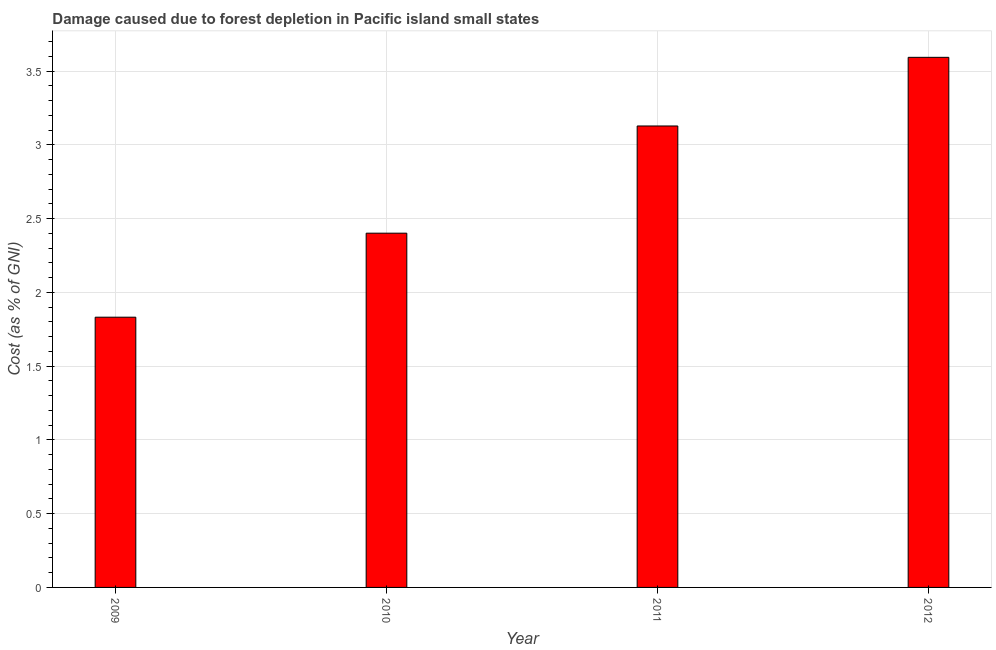Does the graph contain any zero values?
Provide a short and direct response. No. Does the graph contain grids?
Your answer should be very brief. Yes. What is the title of the graph?
Offer a very short reply. Damage caused due to forest depletion in Pacific island small states. What is the label or title of the X-axis?
Ensure brevity in your answer.  Year. What is the label or title of the Y-axis?
Your answer should be compact. Cost (as % of GNI). What is the damage caused due to forest depletion in 2010?
Give a very brief answer. 2.4. Across all years, what is the maximum damage caused due to forest depletion?
Offer a terse response. 3.59. Across all years, what is the minimum damage caused due to forest depletion?
Your answer should be very brief. 1.83. What is the sum of the damage caused due to forest depletion?
Give a very brief answer. 10.96. What is the difference between the damage caused due to forest depletion in 2009 and 2011?
Give a very brief answer. -1.3. What is the average damage caused due to forest depletion per year?
Make the answer very short. 2.74. What is the median damage caused due to forest depletion?
Provide a short and direct response. 2.77. In how many years, is the damage caused due to forest depletion greater than 0.6 %?
Give a very brief answer. 4. What is the ratio of the damage caused due to forest depletion in 2009 to that in 2010?
Keep it short and to the point. 0.76. What is the difference between the highest and the second highest damage caused due to forest depletion?
Make the answer very short. 0.47. What is the difference between the highest and the lowest damage caused due to forest depletion?
Make the answer very short. 1.76. In how many years, is the damage caused due to forest depletion greater than the average damage caused due to forest depletion taken over all years?
Offer a terse response. 2. How many bars are there?
Make the answer very short. 4. Are all the bars in the graph horizontal?
Offer a very short reply. No. How many years are there in the graph?
Your response must be concise. 4. Are the values on the major ticks of Y-axis written in scientific E-notation?
Give a very brief answer. No. What is the Cost (as % of GNI) in 2009?
Provide a succinct answer. 1.83. What is the Cost (as % of GNI) of 2010?
Provide a short and direct response. 2.4. What is the Cost (as % of GNI) in 2011?
Ensure brevity in your answer.  3.13. What is the Cost (as % of GNI) in 2012?
Your response must be concise. 3.59. What is the difference between the Cost (as % of GNI) in 2009 and 2010?
Your response must be concise. -0.57. What is the difference between the Cost (as % of GNI) in 2009 and 2011?
Your answer should be compact. -1.3. What is the difference between the Cost (as % of GNI) in 2009 and 2012?
Offer a very short reply. -1.76. What is the difference between the Cost (as % of GNI) in 2010 and 2011?
Your answer should be very brief. -0.73. What is the difference between the Cost (as % of GNI) in 2010 and 2012?
Offer a terse response. -1.19. What is the difference between the Cost (as % of GNI) in 2011 and 2012?
Ensure brevity in your answer.  -0.47. What is the ratio of the Cost (as % of GNI) in 2009 to that in 2010?
Keep it short and to the point. 0.76. What is the ratio of the Cost (as % of GNI) in 2009 to that in 2011?
Your answer should be very brief. 0.59. What is the ratio of the Cost (as % of GNI) in 2009 to that in 2012?
Offer a very short reply. 0.51. What is the ratio of the Cost (as % of GNI) in 2010 to that in 2011?
Provide a short and direct response. 0.77. What is the ratio of the Cost (as % of GNI) in 2010 to that in 2012?
Your response must be concise. 0.67. What is the ratio of the Cost (as % of GNI) in 2011 to that in 2012?
Provide a succinct answer. 0.87. 